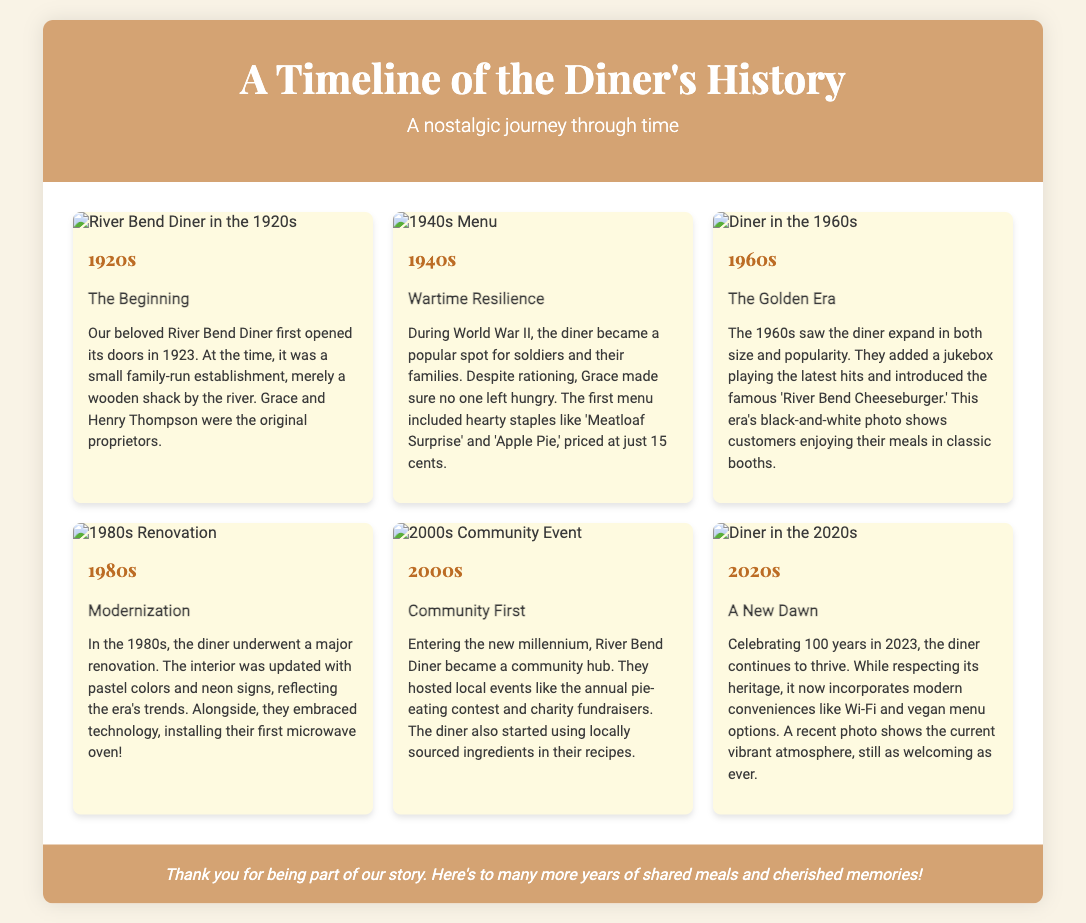What year did the River Bend Diner first open? The document states that the Diner first opened its doors in 1923.
Answer: 1923 Who were the original proprietors of the diner? The original proprietors mentioned in the document are Grace and Henry Thompson.
Answer: Grace and Henry Thompson What was the price of items on the first menu? The document notes that the first menu included items priced at just 15 cents.
Answer: 15 cents What iconic menu item was introduced in the 1960s? According to the document, the famous 'River Bend Cheeseburger' was introduced during the 1960s.
Answer: River Bend Cheeseburger What significant change happened to the diner in the 1980s? The diner underwent a major renovation in the 1980s, updating the interior decor and embracing technology.
Answer: Major renovation In what decade did the diner start using locally sourced ingredients? The document indicates that the diner began using locally sourced ingredients in the 2000s.
Answer: 2000s How many years has the diner celebrated as of 2023? The document celebrates the diner’s 100 years anniversary in 2023.
Answer: 100 years What type of community event does the diner host? The document mentions an annual pie-eating contest as one of the community events hosted by the diner.
Answer: Annual pie-eating contest What modern conveniences does the diner incorporate in the 2020s? The document outlines that the diner now includes Wi-Fi and vegan menu options in the 2020s.
Answer: Wi-Fi and vegan menu options 